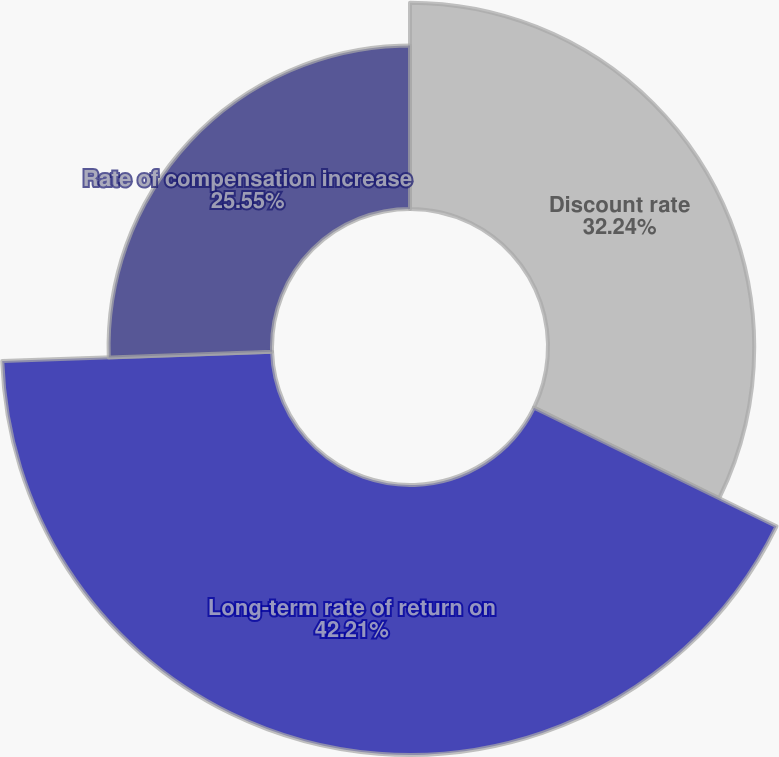<chart> <loc_0><loc_0><loc_500><loc_500><pie_chart><fcel>Discount rate<fcel>Long-term rate of return on<fcel>Rate of compensation increase<nl><fcel>32.24%<fcel>42.21%<fcel>25.55%<nl></chart> 